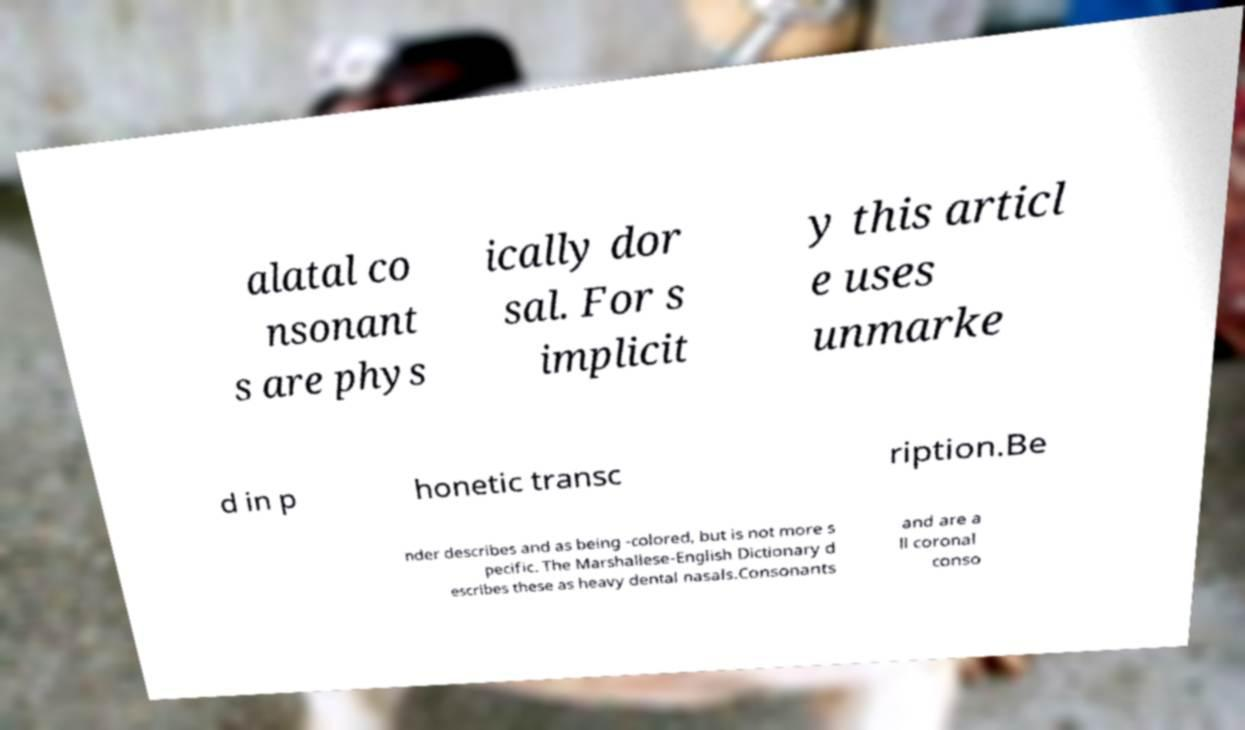What messages or text are displayed in this image? I need them in a readable, typed format. alatal co nsonant s are phys ically dor sal. For s implicit y this articl e uses unmarke d in p honetic transc ription.Be nder describes and as being -colored, but is not more s pecific. The Marshallese-English Dictionary d escribes these as heavy dental nasals.Consonants and are a ll coronal conso 